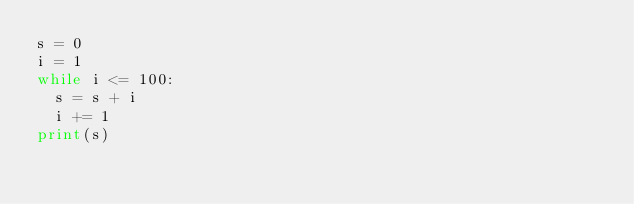Convert code to text. <code><loc_0><loc_0><loc_500><loc_500><_Python_>s = 0
i = 1
while i <= 100:
  s = s + i
  i += 1
print(s)</code> 